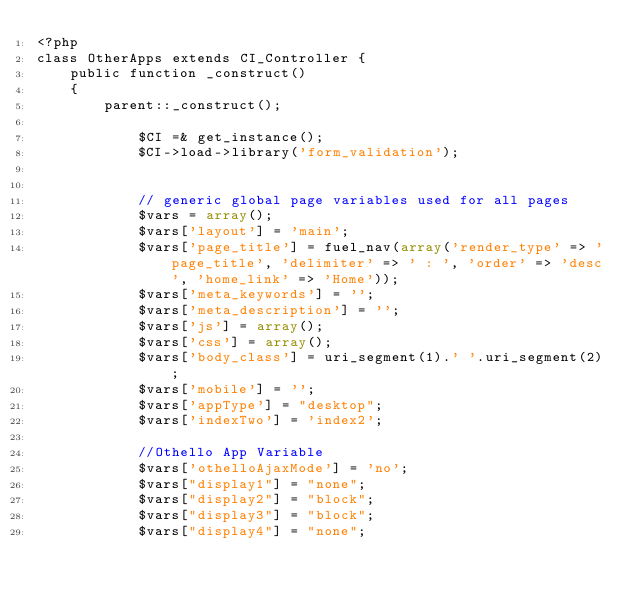Convert code to text. <code><loc_0><loc_0><loc_500><loc_500><_PHP_><?php
class OtherApps extends CI_Controller {
    public function _construct()
    {
        parent::_construct();
        
            $CI =& get_instance();
            $CI->load->library('form_validation');
            
            
            // generic global page variables used for all pages
            $vars = array();
            $vars['layout'] = 'main';
            $vars['page_title'] = fuel_nav(array('render_type' => 'page_title', 'delimiter' => ' : ', 'order' => 'desc', 'home_link' => 'Home'));
            $vars['meta_keywords'] = '';
            $vars['meta_description'] = '';
            $vars['js'] = array();
            $vars['css'] = array();
            $vars['body_class'] = uri_segment(1).' '.uri_segment(2);
            $vars['mobile'] = '';
            $vars['appType'] = "desktop";
            $vars['indexTwo'] = 'index2';
            
            //Othello App Variable
            $vars['othelloAjaxMode'] = 'no';
            $vars["display1"] = "none";
            $vars["display2"] = "block";
            $vars["display3"] = "block";
            $vars["display4"] = "none";</code> 